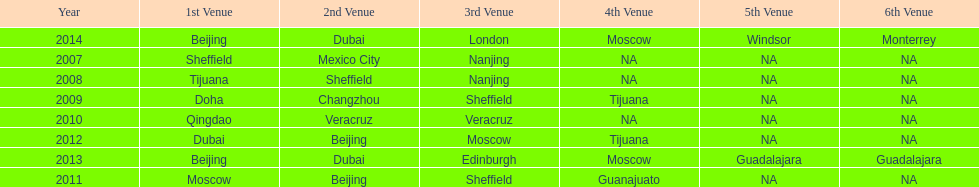Which two venue has no nations from 2007-2012 5th Venue, 6th Venue. 